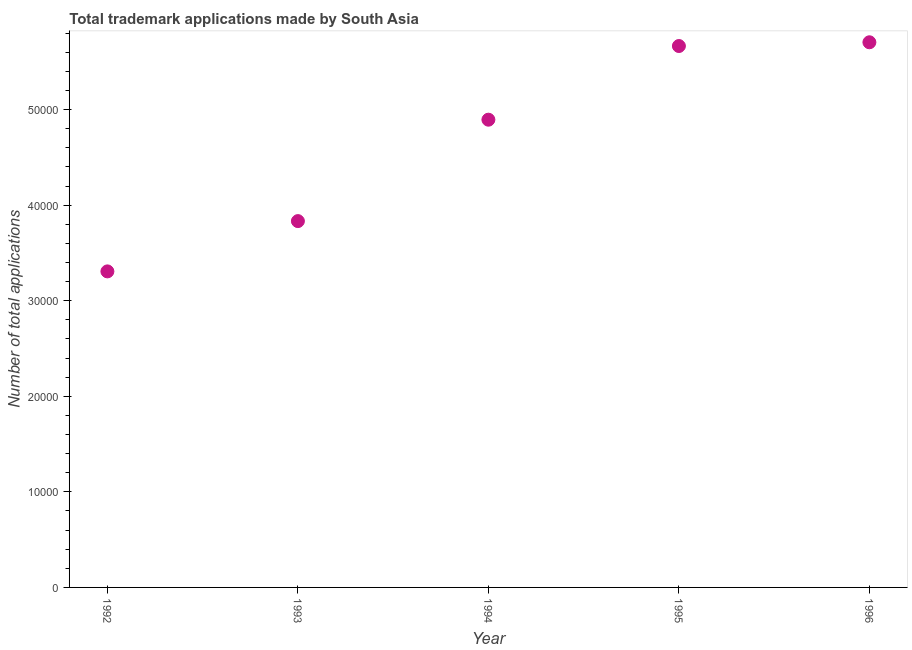What is the number of trademark applications in 1996?
Offer a very short reply. 5.71e+04. Across all years, what is the maximum number of trademark applications?
Make the answer very short. 5.71e+04. Across all years, what is the minimum number of trademark applications?
Your response must be concise. 3.31e+04. In which year was the number of trademark applications maximum?
Provide a short and direct response. 1996. In which year was the number of trademark applications minimum?
Your answer should be very brief. 1992. What is the sum of the number of trademark applications?
Offer a terse response. 2.34e+05. What is the difference between the number of trademark applications in 1993 and 1996?
Your answer should be very brief. -1.87e+04. What is the average number of trademark applications per year?
Offer a terse response. 4.68e+04. What is the median number of trademark applications?
Provide a short and direct response. 4.90e+04. What is the ratio of the number of trademark applications in 1992 to that in 1995?
Ensure brevity in your answer.  0.58. What is the difference between the highest and the second highest number of trademark applications?
Provide a short and direct response. 392. Is the sum of the number of trademark applications in 1994 and 1996 greater than the maximum number of trademark applications across all years?
Your answer should be compact. Yes. What is the difference between the highest and the lowest number of trademark applications?
Your answer should be very brief. 2.40e+04. Are the values on the major ticks of Y-axis written in scientific E-notation?
Your response must be concise. No. Does the graph contain any zero values?
Offer a very short reply. No. What is the title of the graph?
Provide a short and direct response. Total trademark applications made by South Asia. What is the label or title of the Y-axis?
Keep it short and to the point. Number of total applications. What is the Number of total applications in 1992?
Your response must be concise. 3.31e+04. What is the Number of total applications in 1993?
Your response must be concise. 3.83e+04. What is the Number of total applications in 1994?
Offer a very short reply. 4.90e+04. What is the Number of total applications in 1995?
Offer a very short reply. 5.67e+04. What is the Number of total applications in 1996?
Give a very brief answer. 5.71e+04. What is the difference between the Number of total applications in 1992 and 1993?
Give a very brief answer. -5263. What is the difference between the Number of total applications in 1992 and 1994?
Your answer should be very brief. -1.59e+04. What is the difference between the Number of total applications in 1992 and 1995?
Provide a short and direct response. -2.36e+04. What is the difference between the Number of total applications in 1992 and 1996?
Provide a succinct answer. -2.40e+04. What is the difference between the Number of total applications in 1993 and 1994?
Offer a terse response. -1.06e+04. What is the difference between the Number of total applications in 1993 and 1995?
Provide a succinct answer. -1.83e+04. What is the difference between the Number of total applications in 1993 and 1996?
Make the answer very short. -1.87e+04. What is the difference between the Number of total applications in 1994 and 1995?
Offer a terse response. -7709. What is the difference between the Number of total applications in 1994 and 1996?
Make the answer very short. -8101. What is the difference between the Number of total applications in 1995 and 1996?
Ensure brevity in your answer.  -392. What is the ratio of the Number of total applications in 1992 to that in 1993?
Offer a terse response. 0.86. What is the ratio of the Number of total applications in 1992 to that in 1994?
Provide a succinct answer. 0.68. What is the ratio of the Number of total applications in 1992 to that in 1995?
Your answer should be very brief. 0.58. What is the ratio of the Number of total applications in 1992 to that in 1996?
Provide a short and direct response. 0.58. What is the ratio of the Number of total applications in 1993 to that in 1994?
Make the answer very short. 0.78. What is the ratio of the Number of total applications in 1993 to that in 1995?
Keep it short and to the point. 0.68. What is the ratio of the Number of total applications in 1993 to that in 1996?
Your response must be concise. 0.67. What is the ratio of the Number of total applications in 1994 to that in 1995?
Provide a short and direct response. 0.86. What is the ratio of the Number of total applications in 1994 to that in 1996?
Make the answer very short. 0.86. 